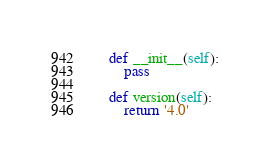Convert code to text. <code><loc_0><loc_0><loc_500><loc_500><_Python_>    def __init__(self):
        pass

    def version(self):
        return '4.0'
</code> 